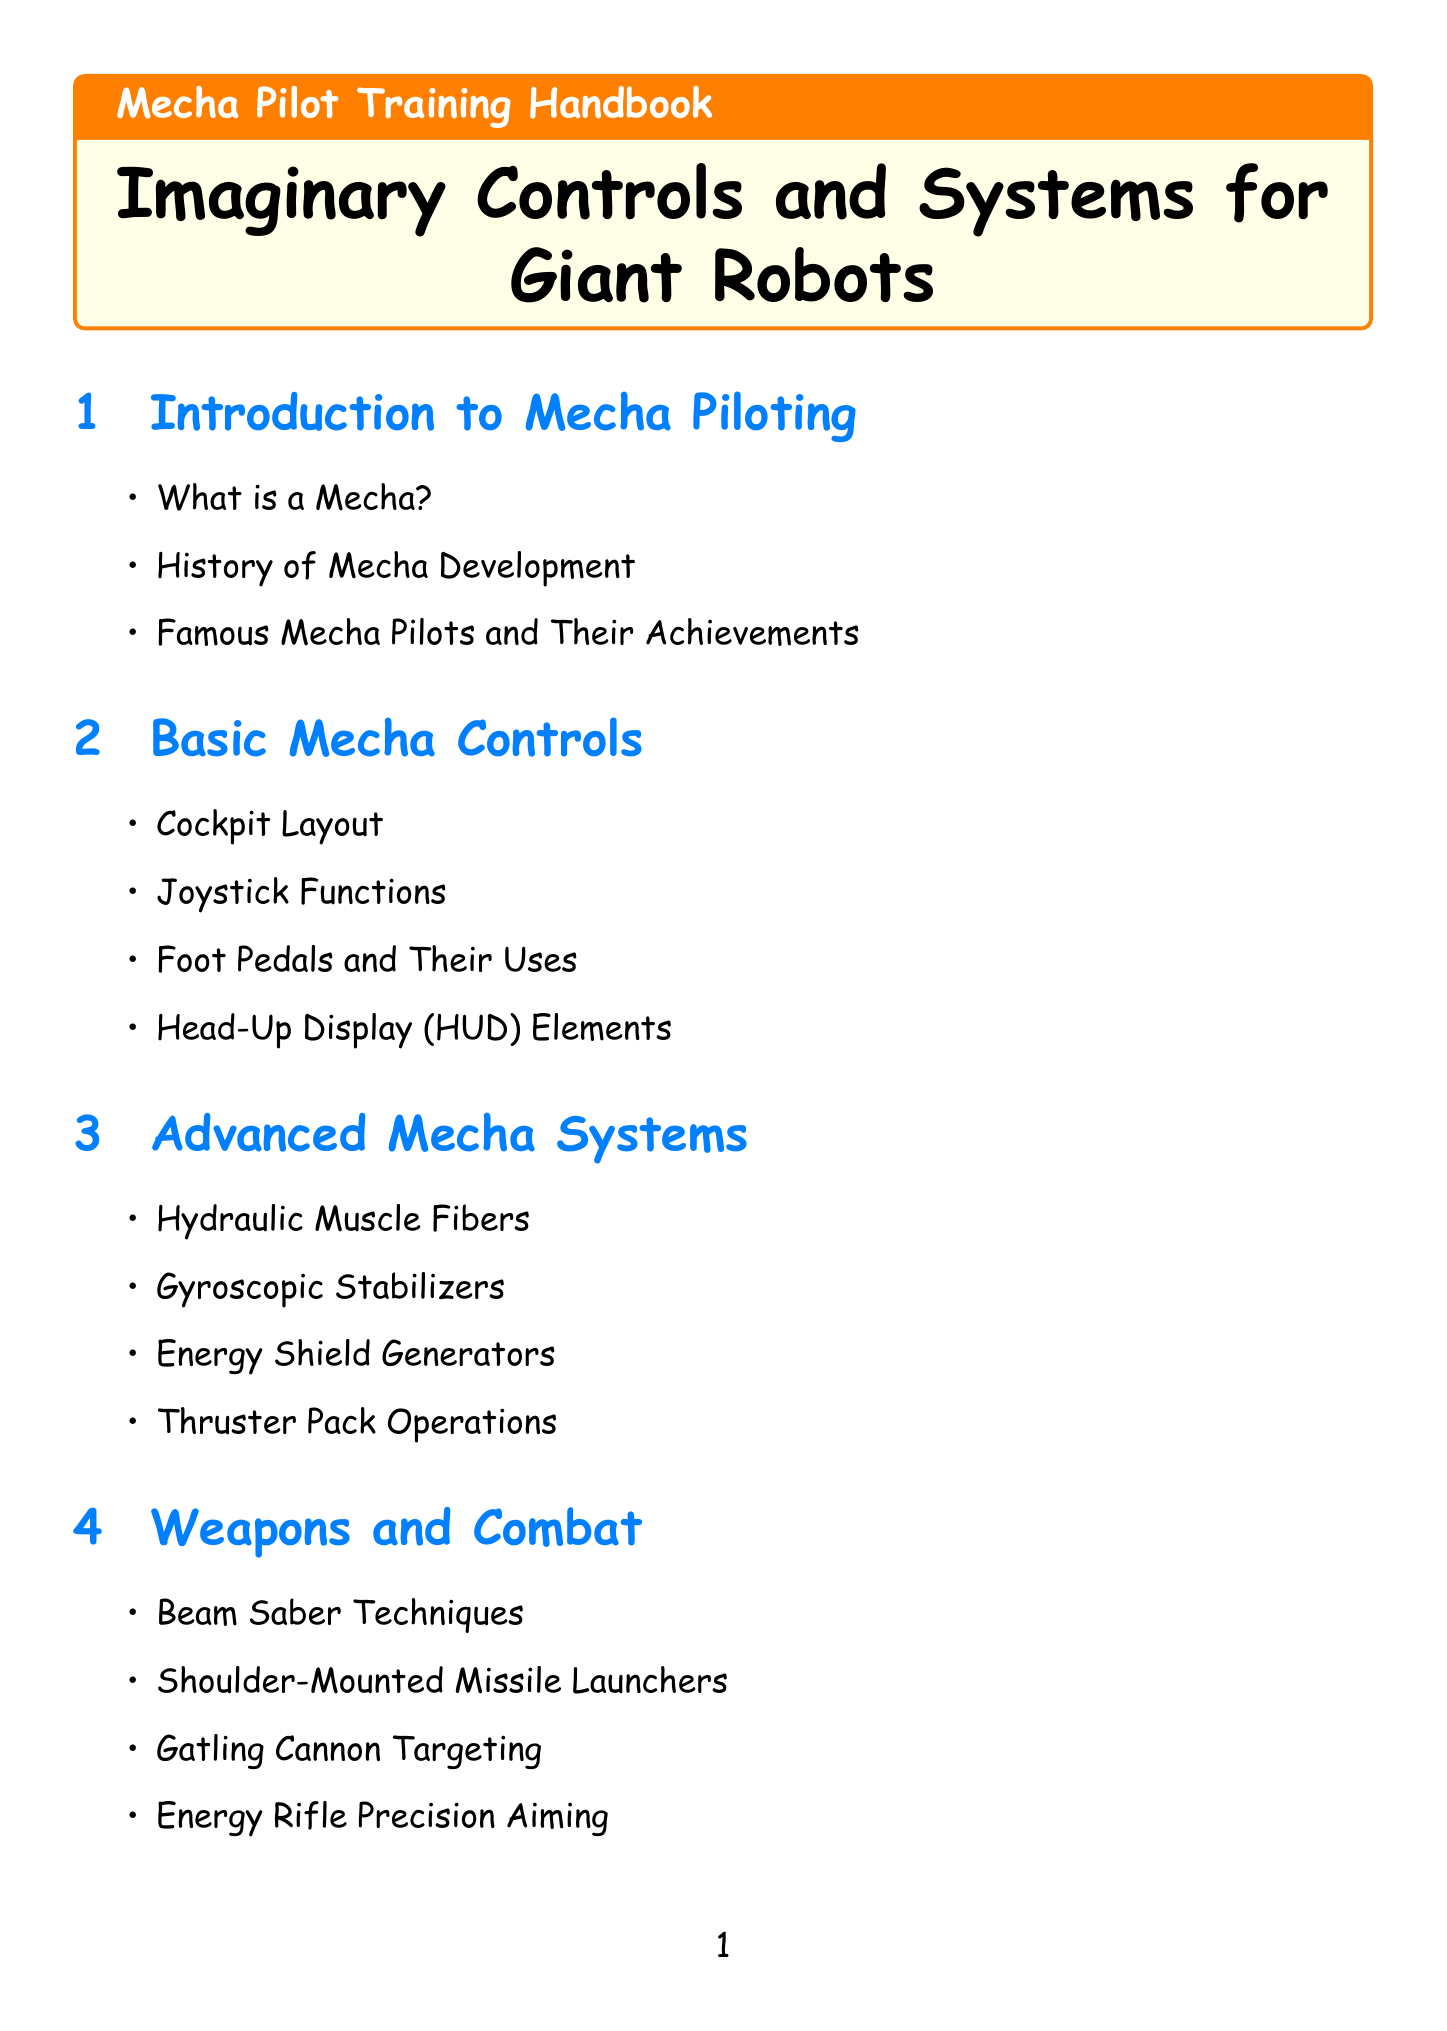What is the title of the handbook? The title is clearly mentioned at the beginning of the document.
Answer: Mecha Pilot Training Handbook: Imaginary Controls and Systems for Giant Robots How many chapters are there in the handbook? The total number of chapters can be counted from the chapters section of the document.
Answer: 10 What is the focus of the chapter "Future of Mecha Technology"? The chapter clearly lists topics of modern advancement in mecha piloting technology.
Answer: AI-Assisted Piloting Systems Who are some legendary mecha pilots mentioned in the document? The Hall of Fame section provides names of notable figures in mecha piloting.
Answer: Amuro Ray, Koji Kabuto, Shinji Ikari What is one type of weapon discussed in the "Weapons and Combat" chapter? This section outlines specific weapons used in mecha combat.
Answer: Beam Saber Techniques What type of training is emphasized in the chapter on physical training? The chapter summarises specific physical skills needed for successful piloting.
Answer: G-Force Resistance Exercises What is the purpose of the "Emergency Procedures" section? This section is focused on actions to take in critical situations during operations.
Answer: Ejection Seat Protocol Which chapter covers the topic of customizing a mecha? The chapter specifically dedicated to customization highlights various personalization options.
Answer: Mecha Customization What does the "Glossary of Mecha Terms" section include? This appendix lists important terminology related to mecha operations.
Answer: Technical terms and slang used by mecha pilots and engineers 